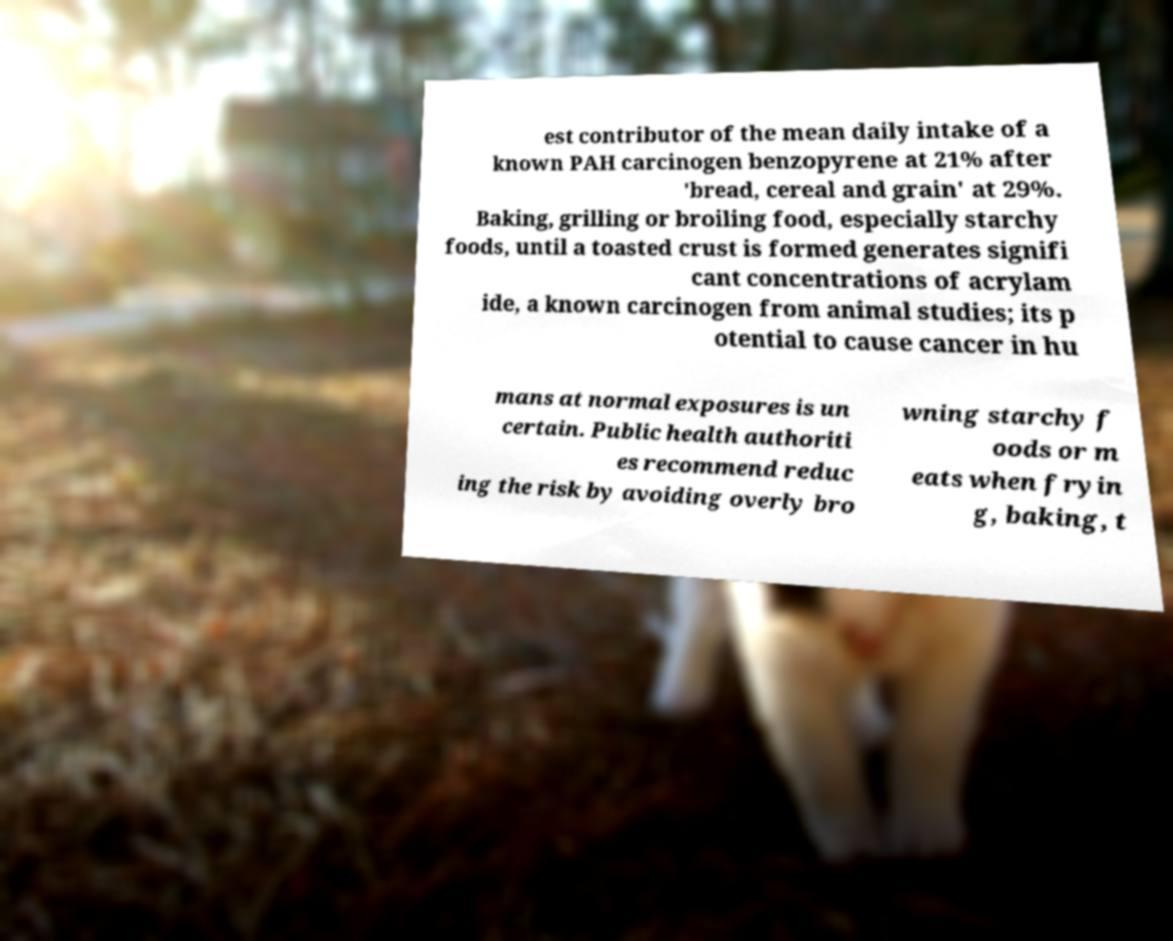Please identify and transcribe the text found in this image. est contributor of the mean daily intake of a known PAH carcinogen benzopyrene at 21% after 'bread, cereal and grain' at 29%. Baking, grilling or broiling food, especially starchy foods, until a toasted crust is formed generates signifi cant concentrations of acrylam ide, a known carcinogen from animal studies; its p otential to cause cancer in hu mans at normal exposures is un certain. Public health authoriti es recommend reduc ing the risk by avoiding overly bro wning starchy f oods or m eats when fryin g, baking, t 